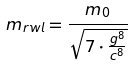Convert formula to latex. <formula><loc_0><loc_0><loc_500><loc_500>m _ { r w l } = \frac { m _ { 0 } } { \sqrt { 7 \cdot \frac { g ^ { 8 } } { c ^ { 8 } } } }</formula> 